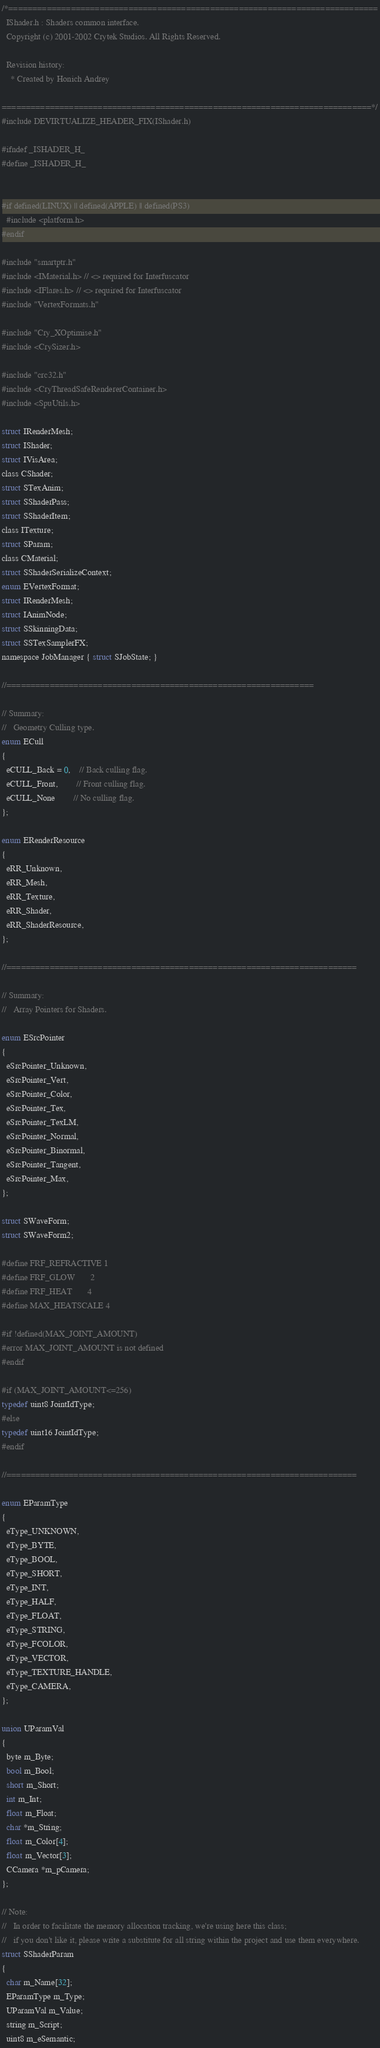Convert code to text. <code><loc_0><loc_0><loc_500><loc_500><_C_>/*=============================================================================
  IShader.h : Shaders common interface.
  Copyright (c) 2001-2002 Crytek Studios. All Rights Reserved.

  Revision history:
    * Created by Honich Andrey

=============================================================================*/
#include DEVIRTUALIZE_HEADER_FIX(IShader.h)

#ifndef _ISHADER_H_
#define _ISHADER_H_


#if defined(LINUX) || defined(APPLE) || defined(PS3)
  #include <platform.h>
#endif

#include "smartptr.h"
#include <IMaterial.h> // <> required for Interfuscator
#include <IFlares.h> // <> required for Interfuscator
#include "VertexFormats.h"

#include "Cry_XOptimise.h"
#include <CrySizer.h>

#include "crc32.h"
#include <CryThreadSafeRendererContainer.h>
#include <SpuUtils.h>

struct IRenderMesh;
struct IShader;
struct IVisArea;
class CShader;
struct STexAnim;
struct SShaderPass;
struct SShaderItem;
class ITexture;
struct SParam;
class CMaterial;
struct SShaderSerializeContext;
enum EVertexFormat;
struct IRenderMesh;
struct IAnimNode;
struct SSkinningData;
struct SSTexSamplerFX;
namespace JobManager { struct SJobState; }

//================================================================

// Summary:
//	 Geometry Culling type.
enum ECull
{
  eCULL_Back = 0,	// Back culling flag.
  eCULL_Front,		// Front culling flag.
  eCULL_None		// No culling flag.
};

enum ERenderResource
{
  eRR_Unknown,
  eRR_Mesh,
  eRR_Texture,
  eRR_Shader,
  eRR_ShaderResource,
};

//=========================================================================

// Summary:
//	 Array Pointers for Shaders.

enum ESrcPointer
{
  eSrcPointer_Unknown,
  eSrcPointer_Vert,
  eSrcPointer_Color,
  eSrcPointer_Tex,
  eSrcPointer_TexLM,
  eSrcPointer_Normal,
  eSrcPointer_Binormal,
  eSrcPointer_Tangent,
  eSrcPointer_Max,
};

struct SWaveForm;
struct SWaveForm2;

#define FRF_REFRACTIVE 1
#define FRF_GLOW       2
#define FRF_HEAT       4
#define MAX_HEATSCALE 4

#if !defined(MAX_JOINT_AMOUNT)
#error MAX_JOINT_AMOUNT is not defined
#endif

#if (MAX_JOINT_AMOUNT<=256)
typedef uint8 JointIdType;
#else
typedef uint16 JointIdType;				
#endif

//=========================================================================

enum EParamType
{
  eType_UNKNOWN,
  eType_BYTE,
  eType_BOOL,
  eType_SHORT,
  eType_INT,
  eType_HALF,
  eType_FLOAT,
  eType_STRING,
  eType_FCOLOR,
  eType_VECTOR,
  eType_TEXTURE_HANDLE,
  eType_CAMERA,
};

union UParamVal
{
  byte m_Byte;
  bool m_Bool;
  short m_Short;
  int m_Int;
  float m_Float;
  char *m_String;
  float m_Color[4];
  float m_Vector[3];
  CCamera *m_pCamera;
};

// Note:
//	 In order to facilitate the memory allocation tracking, we're using here this class;
//	 if you don't like it, please write a substitute for all string within the project and use them everywhere.
struct SShaderParam
{
  char m_Name[32];
  EParamType m_Type;
  UParamVal m_Value;
  string m_Script;
  uint8 m_eSemantic;
</code> 